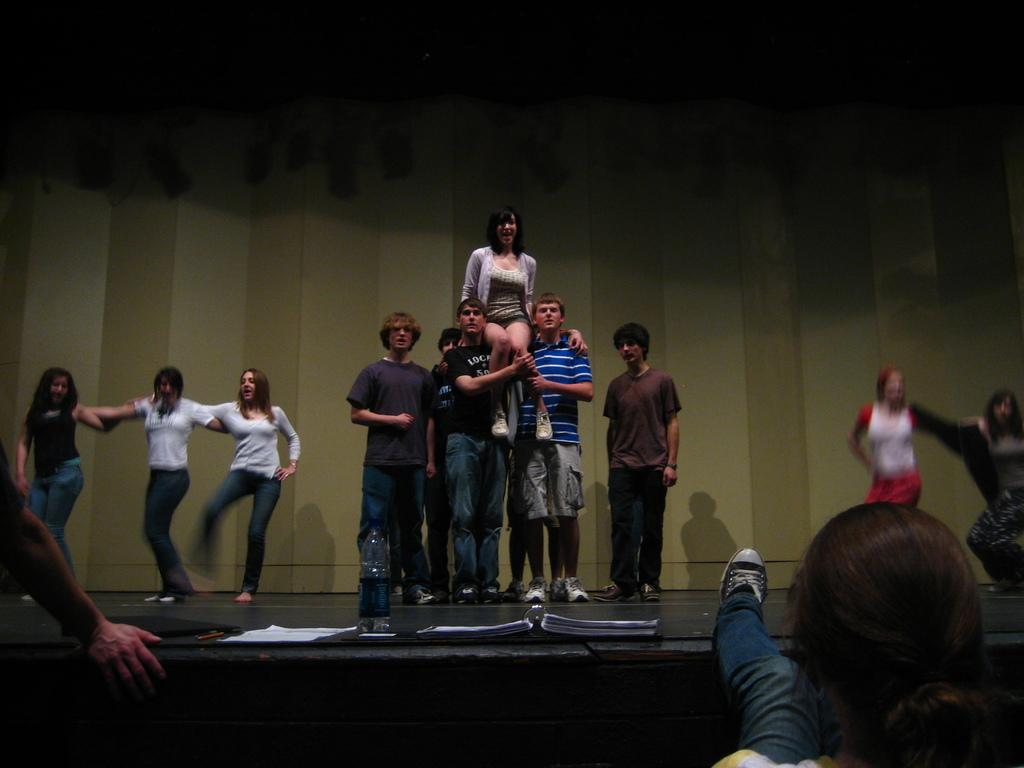What are the people in the image doing? There are people standing and dancing in the image. Where are the people performing their actions? The people are on a stage. Can you describe the arrangement of the people on the stage? There are two persons in the front of the stage. What other objects are present on the stage? There are papers and a bottle on the stage. What type of dolls are being used by the grandmother and uncle in the image? There is no grandmother, uncle, or dolls present in the image. 